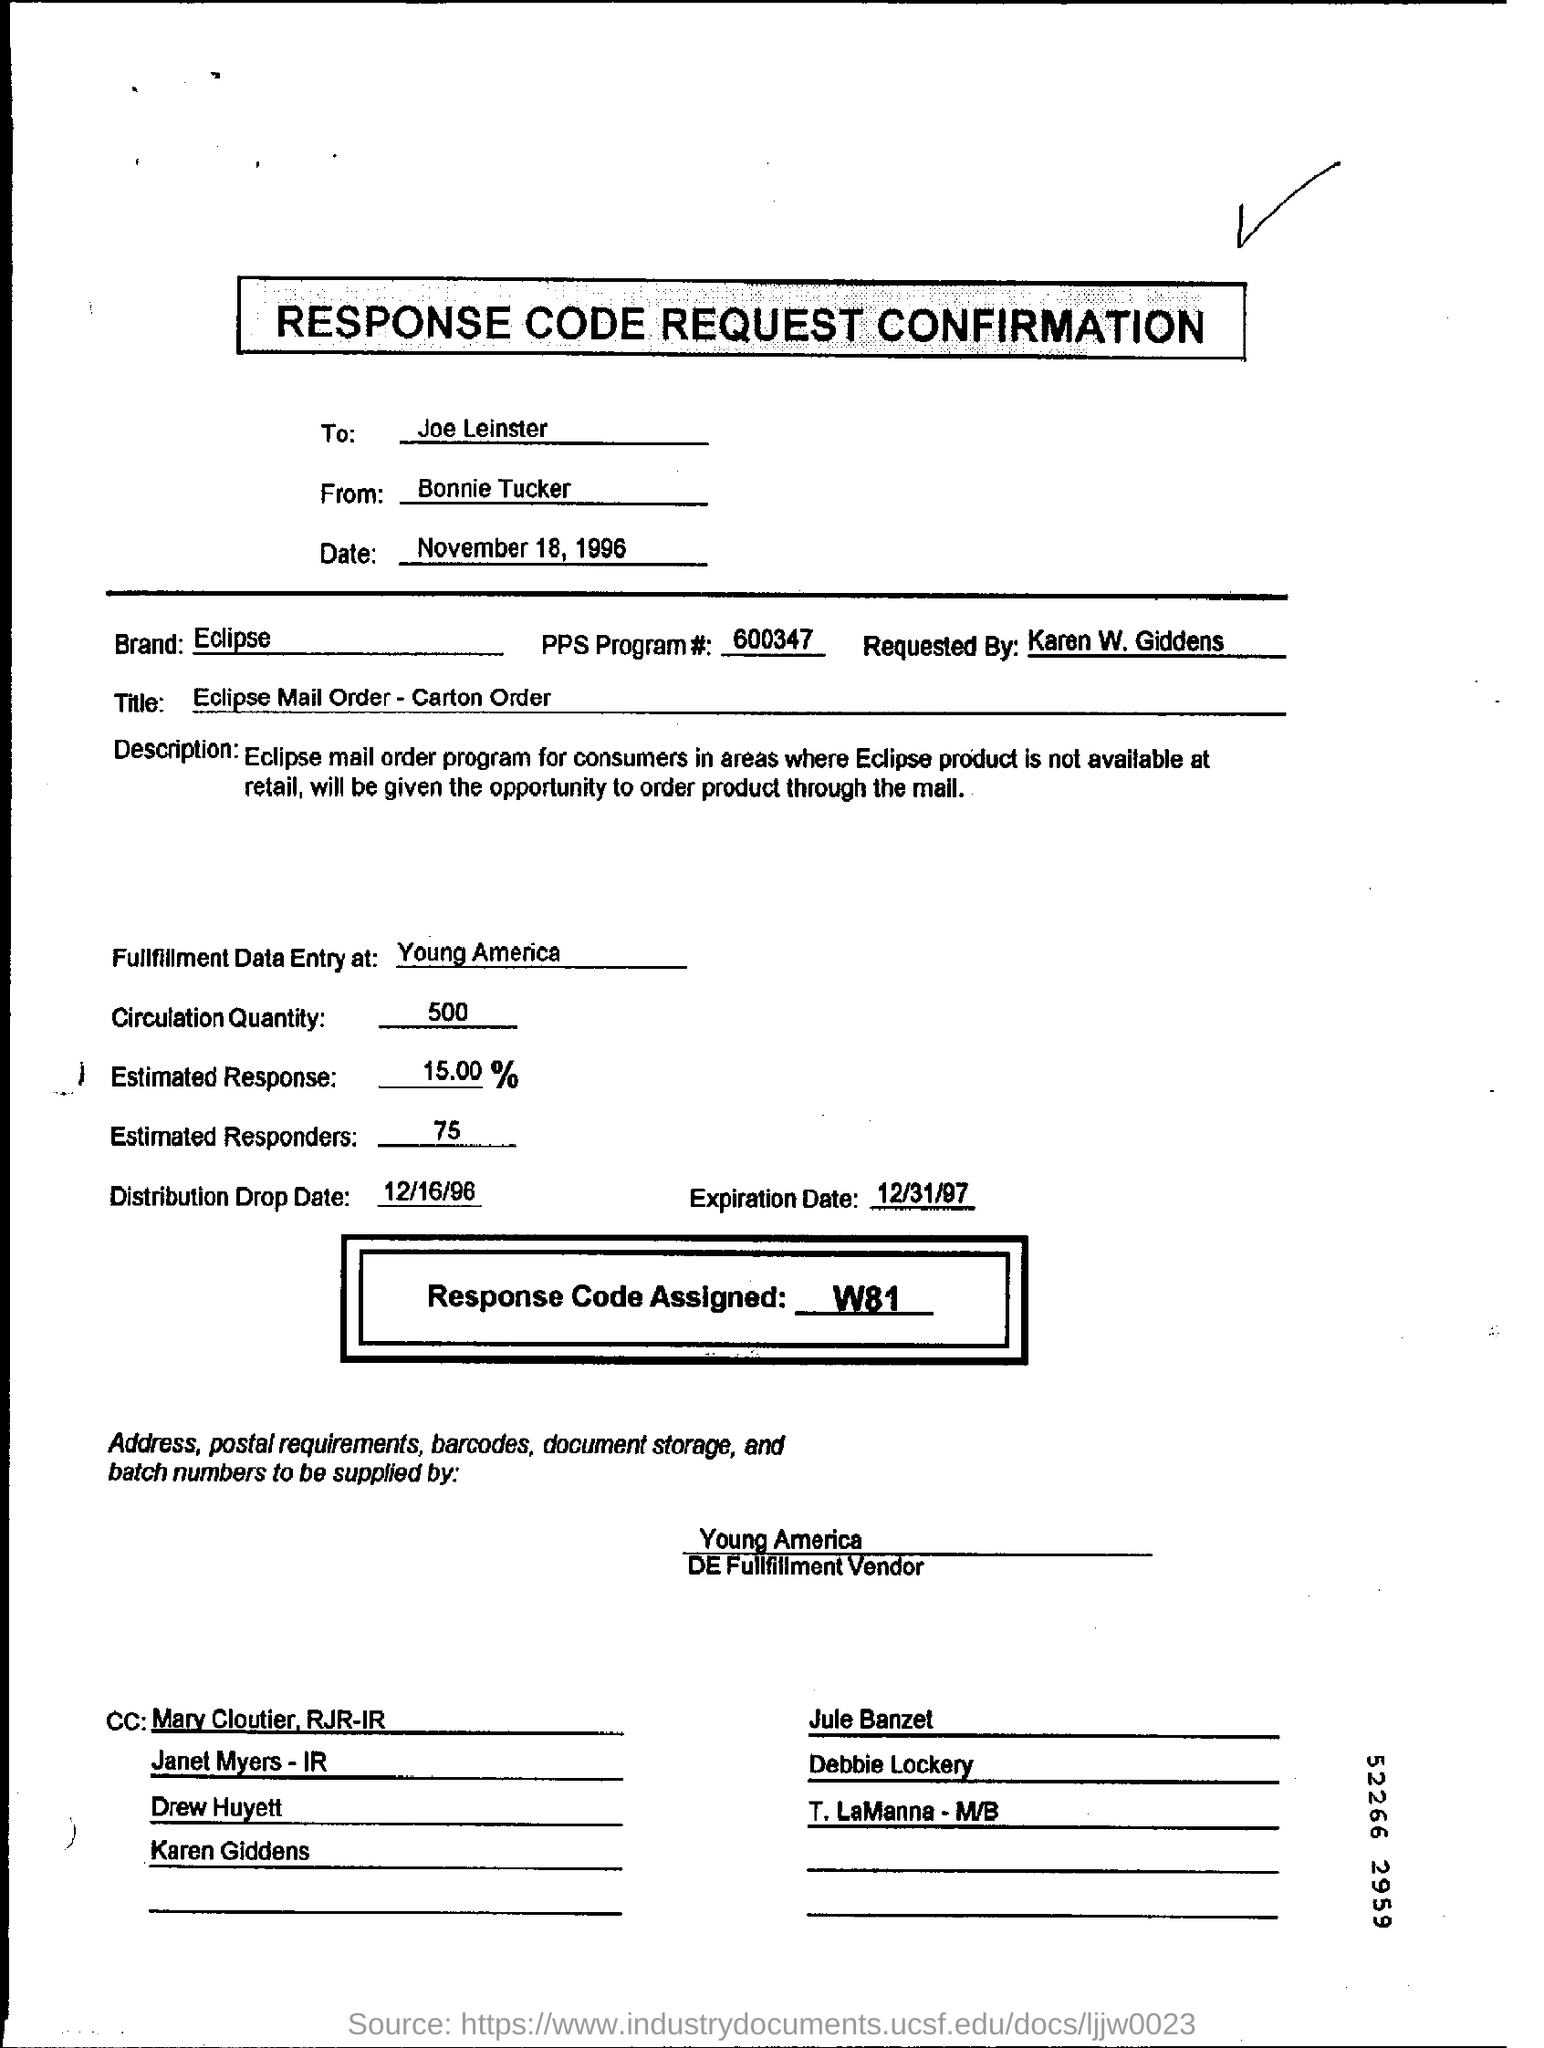Point out several critical features in this image. What is the response code assigned?" is a question that requires a response. The code is likely assigned to a specific situation or scenario, and further explanation or clarification may be necessary. The circulation quantity is 500.. The distribution drop date is December 16, 1996. 